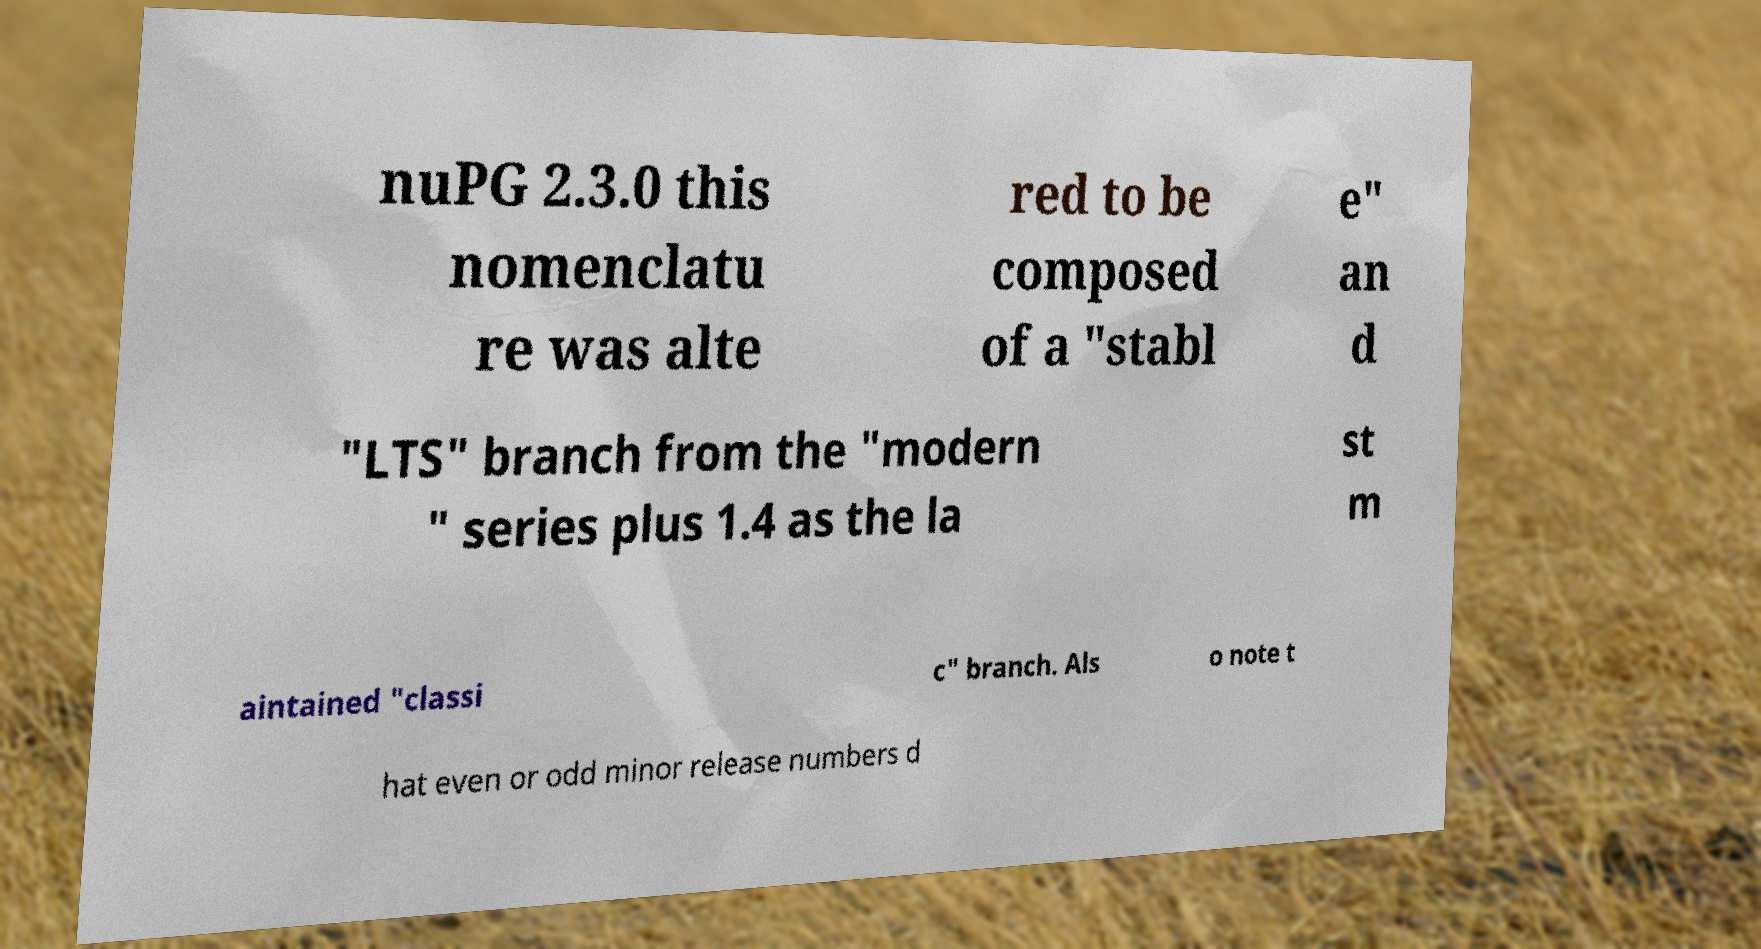I need the written content from this picture converted into text. Can you do that? nuPG 2.3.0 this nomenclatu re was alte red to be composed of a "stabl e" an d "LTS" branch from the "modern " series plus 1.4 as the la st m aintained "classi c" branch. Als o note t hat even or odd minor release numbers d 